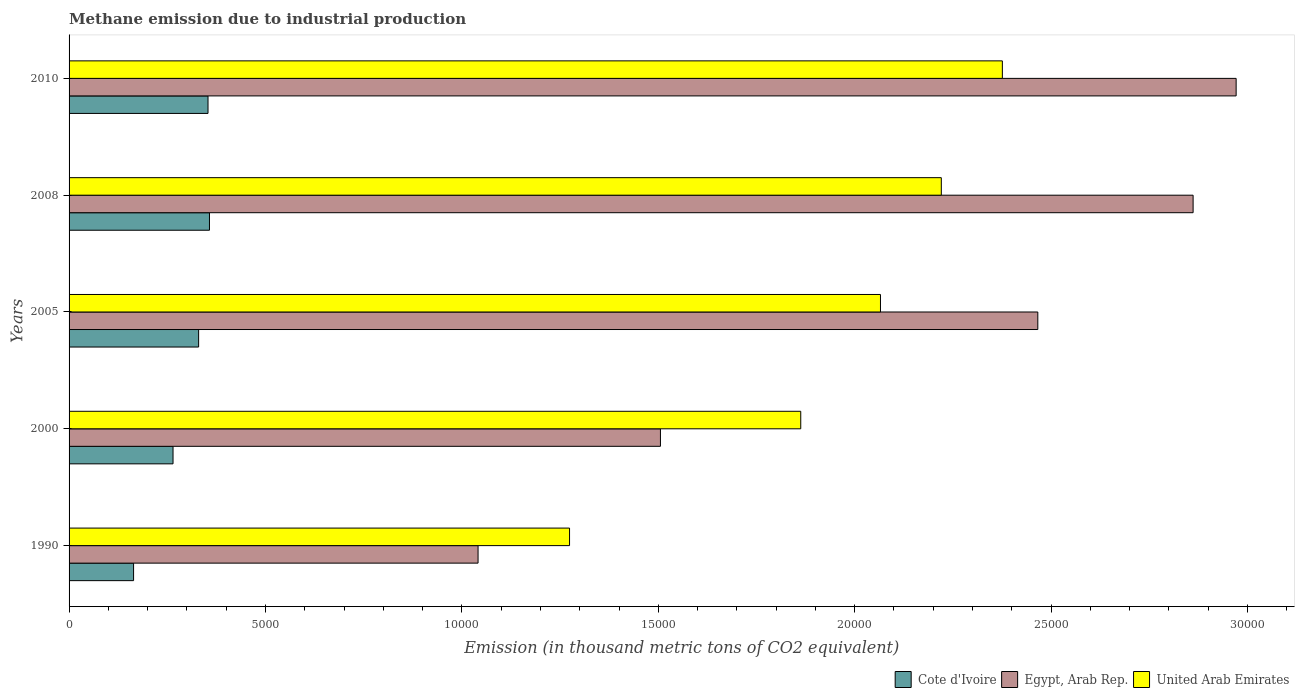How many different coloured bars are there?
Offer a terse response. 3. Are the number of bars per tick equal to the number of legend labels?
Make the answer very short. Yes. What is the label of the 3rd group of bars from the top?
Offer a terse response. 2005. What is the amount of methane emitted in United Arab Emirates in 2008?
Provide a short and direct response. 2.22e+04. Across all years, what is the maximum amount of methane emitted in United Arab Emirates?
Your answer should be very brief. 2.38e+04. Across all years, what is the minimum amount of methane emitted in Cote d'Ivoire?
Offer a very short reply. 1642.3. In which year was the amount of methane emitted in United Arab Emirates maximum?
Ensure brevity in your answer.  2010. What is the total amount of methane emitted in Egypt, Arab Rep. in the graph?
Provide a succinct answer. 1.08e+05. What is the difference between the amount of methane emitted in Egypt, Arab Rep. in 2000 and that in 2008?
Your answer should be very brief. -1.36e+04. What is the difference between the amount of methane emitted in Egypt, Arab Rep. in 1990 and the amount of methane emitted in United Arab Emirates in 2008?
Make the answer very short. -1.18e+04. What is the average amount of methane emitted in Egypt, Arab Rep. per year?
Give a very brief answer. 2.17e+04. In the year 2010, what is the difference between the amount of methane emitted in United Arab Emirates and amount of methane emitted in Cote d'Ivoire?
Provide a short and direct response. 2.02e+04. In how many years, is the amount of methane emitted in Cote d'Ivoire greater than 7000 thousand metric tons?
Give a very brief answer. 0. What is the ratio of the amount of methane emitted in United Arab Emirates in 2005 to that in 2010?
Provide a short and direct response. 0.87. Is the amount of methane emitted in Cote d'Ivoire in 2005 less than that in 2010?
Your answer should be compact. Yes. Is the difference between the amount of methane emitted in United Arab Emirates in 2000 and 2010 greater than the difference between the amount of methane emitted in Cote d'Ivoire in 2000 and 2010?
Your answer should be compact. No. What is the difference between the highest and the second highest amount of methane emitted in Egypt, Arab Rep.?
Your answer should be compact. 1095.6. What is the difference between the highest and the lowest amount of methane emitted in Cote d'Ivoire?
Keep it short and to the point. 1932.1. Is the sum of the amount of methane emitted in United Arab Emirates in 2000 and 2010 greater than the maximum amount of methane emitted in Cote d'Ivoire across all years?
Keep it short and to the point. Yes. What does the 1st bar from the top in 2008 represents?
Offer a very short reply. United Arab Emirates. What does the 3rd bar from the bottom in 2010 represents?
Your answer should be compact. United Arab Emirates. Is it the case that in every year, the sum of the amount of methane emitted in Egypt, Arab Rep. and amount of methane emitted in Cote d'Ivoire is greater than the amount of methane emitted in United Arab Emirates?
Provide a short and direct response. No. Are all the bars in the graph horizontal?
Offer a terse response. Yes. What is the difference between two consecutive major ticks on the X-axis?
Give a very brief answer. 5000. Does the graph contain any zero values?
Offer a terse response. No. Does the graph contain grids?
Keep it short and to the point. No. How many legend labels are there?
Your response must be concise. 3. What is the title of the graph?
Make the answer very short. Methane emission due to industrial production. What is the label or title of the X-axis?
Your answer should be very brief. Emission (in thousand metric tons of CO2 equivalent). What is the Emission (in thousand metric tons of CO2 equivalent) in Cote d'Ivoire in 1990?
Ensure brevity in your answer.  1642.3. What is the Emission (in thousand metric tons of CO2 equivalent) of Egypt, Arab Rep. in 1990?
Keep it short and to the point. 1.04e+04. What is the Emission (in thousand metric tons of CO2 equivalent) of United Arab Emirates in 1990?
Provide a short and direct response. 1.27e+04. What is the Emission (in thousand metric tons of CO2 equivalent) in Cote d'Ivoire in 2000?
Give a very brief answer. 2646.7. What is the Emission (in thousand metric tons of CO2 equivalent) of Egypt, Arab Rep. in 2000?
Make the answer very short. 1.51e+04. What is the Emission (in thousand metric tons of CO2 equivalent) in United Arab Emirates in 2000?
Your answer should be compact. 1.86e+04. What is the Emission (in thousand metric tons of CO2 equivalent) of Cote d'Ivoire in 2005?
Your answer should be very brief. 3298.2. What is the Emission (in thousand metric tons of CO2 equivalent) in Egypt, Arab Rep. in 2005?
Give a very brief answer. 2.47e+04. What is the Emission (in thousand metric tons of CO2 equivalent) of United Arab Emirates in 2005?
Your answer should be compact. 2.07e+04. What is the Emission (in thousand metric tons of CO2 equivalent) of Cote d'Ivoire in 2008?
Provide a succinct answer. 3574.4. What is the Emission (in thousand metric tons of CO2 equivalent) in Egypt, Arab Rep. in 2008?
Ensure brevity in your answer.  2.86e+04. What is the Emission (in thousand metric tons of CO2 equivalent) in United Arab Emirates in 2008?
Offer a very short reply. 2.22e+04. What is the Emission (in thousand metric tons of CO2 equivalent) in Cote d'Ivoire in 2010?
Your answer should be very brief. 3537.3. What is the Emission (in thousand metric tons of CO2 equivalent) of Egypt, Arab Rep. in 2010?
Your answer should be very brief. 2.97e+04. What is the Emission (in thousand metric tons of CO2 equivalent) of United Arab Emirates in 2010?
Provide a short and direct response. 2.38e+04. Across all years, what is the maximum Emission (in thousand metric tons of CO2 equivalent) in Cote d'Ivoire?
Ensure brevity in your answer.  3574.4. Across all years, what is the maximum Emission (in thousand metric tons of CO2 equivalent) of Egypt, Arab Rep.?
Provide a short and direct response. 2.97e+04. Across all years, what is the maximum Emission (in thousand metric tons of CO2 equivalent) in United Arab Emirates?
Your response must be concise. 2.38e+04. Across all years, what is the minimum Emission (in thousand metric tons of CO2 equivalent) of Cote d'Ivoire?
Make the answer very short. 1642.3. Across all years, what is the minimum Emission (in thousand metric tons of CO2 equivalent) in Egypt, Arab Rep.?
Provide a short and direct response. 1.04e+04. Across all years, what is the minimum Emission (in thousand metric tons of CO2 equivalent) in United Arab Emirates?
Offer a very short reply. 1.27e+04. What is the total Emission (in thousand metric tons of CO2 equivalent) in Cote d'Ivoire in the graph?
Offer a terse response. 1.47e+04. What is the total Emission (in thousand metric tons of CO2 equivalent) in Egypt, Arab Rep. in the graph?
Keep it short and to the point. 1.08e+05. What is the total Emission (in thousand metric tons of CO2 equivalent) of United Arab Emirates in the graph?
Provide a succinct answer. 9.80e+04. What is the difference between the Emission (in thousand metric tons of CO2 equivalent) of Cote d'Ivoire in 1990 and that in 2000?
Give a very brief answer. -1004.4. What is the difference between the Emission (in thousand metric tons of CO2 equivalent) in Egypt, Arab Rep. in 1990 and that in 2000?
Provide a succinct answer. -4642.9. What is the difference between the Emission (in thousand metric tons of CO2 equivalent) of United Arab Emirates in 1990 and that in 2000?
Ensure brevity in your answer.  -5885.7. What is the difference between the Emission (in thousand metric tons of CO2 equivalent) of Cote d'Ivoire in 1990 and that in 2005?
Ensure brevity in your answer.  -1655.9. What is the difference between the Emission (in thousand metric tons of CO2 equivalent) in Egypt, Arab Rep. in 1990 and that in 2005?
Your answer should be very brief. -1.42e+04. What is the difference between the Emission (in thousand metric tons of CO2 equivalent) of United Arab Emirates in 1990 and that in 2005?
Your answer should be compact. -7915.3. What is the difference between the Emission (in thousand metric tons of CO2 equivalent) of Cote d'Ivoire in 1990 and that in 2008?
Offer a terse response. -1932.1. What is the difference between the Emission (in thousand metric tons of CO2 equivalent) in Egypt, Arab Rep. in 1990 and that in 2008?
Provide a succinct answer. -1.82e+04. What is the difference between the Emission (in thousand metric tons of CO2 equivalent) of United Arab Emirates in 1990 and that in 2008?
Your answer should be compact. -9464.3. What is the difference between the Emission (in thousand metric tons of CO2 equivalent) of Cote d'Ivoire in 1990 and that in 2010?
Give a very brief answer. -1895. What is the difference between the Emission (in thousand metric tons of CO2 equivalent) in Egypt, Arab Rep. in 1990 and that in 2010?
Offer a terse response. -1.93e+04. What is the difference between the Emission (in thousand metric tons of CO2 equivalent) of United Arab Emirates in 1990 and that in 2010?
Offer a terse response. -1.10e+04. What is the difference between the Emission (in thousand metric tons of CO2 equivalent) in Cote d'Ivoire in 2000 and that in 2005?
Give a very brief answer. -651.5. What is the difference between the Emission (in thousand metric tons of CO2 equivalent) of Egypt, Arab Rep. in 2000 and that in 2005?
Keep it short and to the point. -9607. What is the difference between the Emission (in thousand metric tons of CO2 equivalent) of United Arab Emirates in 2000 and that in 2005?
Your answer should be very brief. -2029.6. What is the difference between the Emission (in thousand metric tons of CO2 equivalent) in Cote d'Ivoire in 2000 and that in 2008?
Offer a very short reply. -927.7. What is the difference between the Emission (in thousand metric tons of CO2 equivalent) of Egypt, Arab Rep. in 2000 and that in 2008?
Make the answer very short. -1.36e+04. What is the difference between the Emission (in thousand metric tons of CO2 equivalent) in United Arab Emirates in 2000 and that in 2008?
Offer a terse response. -3578.6. What is the difference between the Emission (in thousand metric tons of CO2 equivalent) in Cote d'Ivoire in 2000 and that in 2010?
Your answer should be very brief. -890.6. What is the difference between the Emission (in thousand metric tons of CO2 equivalent) of Egypt, Arab Rep. in 2000 and that in 2010?
Make the answer very short. -1.47e+04. What is the difference between the Emission (in thousand metric tons of CO2 equivalent) in United Arab Emirates in 2000 and that in 2010?
Offer a terse response. -5132.6. What is the difference between the Emission (in thousand metric tons of CO2 equivalent) in Cote d'Ivoire in 2005 and that in 2008?
Your answer should be very brief. -276.2. What is the difference between the Emission (in thousand metric tons of CO2 equivalent) of Egypt, Arab Rep. in 2005 and that in 2008?
Your answer should be very brief. -3953.4. What is the difference between the Emission (in thousand metric tons of CO2 equivalent) of United Arab Emirates in 2005 and that in 2008?
Offer a terse response. -1549. What is the difference between the Emission (in thousand metric tons of CO2 equivalent) in Cote d'Ivoire in 2005 and that in 2010?
Your answer should be very brief. -239.1. What is the difference between the Emission (in thousand metric tons of CO2 equivalent) in Egypt, Arab Rep. in 2005 and that in 2010?
Ensure brevity in your answer.  -5049. What is the difference between the Emission (in thousand metric tons of CO2 equivalent) of United Arab Emirates in 2005 and that in 2010?
Provide a succinct answer. -3103. What is the difference between the Emission (in thousand metric tons of CO2 equivalent) of Cote d'Ivoire in 2008 and that in 2010?
Make the answer very short. 37.1. What is the difference between the Emission (in thousand metric tons of CO2 equivalent) of Egypt, Arab Rep. in 2008 and that in 2010?
Give a very brief answer. -1095.6. What is the difference between the Emission (in thousand metric tons of CO2 equivalent) of United Arab Emirates in 2008 and that in 2010?
Offer a very short reply. -1554. What is the difference between the Emission (in thousand metric tons of CO2 equivalent) of Cote d'Ivoire in 1990 and the Emission (in thousand metric tons of CO2 equivalent) of Egypt, Arab Rep. in 2000?
Keep it short and to the point. -1.34e+04. What is the difference between the Emission (in thousand metric tons of CO2 equivalent) in Cote d'Ivoire in 1990 and the Emission (in thousand metric tons of CO2 equivalent) in United Arab Emirates in 2000?
Your answer should be compact. -1.70e+04. What is the difference between the Emission (in thousand metric tons of CO2 equivalent) in Egypt, Arab Rep. in 1990 and the Emission (in thousand metric tons of CO2 equivalent) in United Arab Emirates in 2000?
Keep it short and to the point. -8214.7. What is the difference between the Emission (in thousand metric tons of CO2 equivalent) of Cote d'Ivoire in 1990 and the Emission (in thousand metric tons of CO2 equivalent) of Egypt, Arab Rep. in 2005?
Offer a terse response. -2.30e+04. What is the difference between the Emission (in thousand metric tons of CO2 equivalent) in Cote d'Ivoire in 1990 and the Emission (in thousand metric tons of CO2 equivalent) in United Arab Emirates in 2005?
Keep it short and to the point. -1.90e+04. What is the difference between the Emission (in thousand metric tons of CO2 equivalent) of Egypt, Arab Rep. in 1990 and the Emission (in thousand metric tons of CO2 equivalent) of United Arab Emirates in 2005?
Provide a succinct answer. -1.02e+04. What is the difference between the Emission (in thousand metric tons of CO2 equivalent) of Cote d'Ivoire in 1990 and the Emission (in thousand metric tons of CO2 equivalent) of Egypt, Arab Rep. in 2008?
Make the answer very short. -2.70e+04. What is the difference between the Emission (in thousand metric tons of CO2 equivalent) of Cote d'Ivoire in 1990 and the Emission (in thousand metric tons of CO2 equivalent) of United Arab Emirates in 2008?
Make the answer very short. -2.06e+04. What is the difference between the Emission (in thousand metric tons of CO2 equivalent) in Egypt, Arab Rep. in 1990 and the Emission (in thousand metric tons of CO2 equivalent) in United Arab Emirates in 2008?
Provide a short and direct response. -1.18e+04. What is the difference between the Emission (in thousand metric tons of CO2 equivalent) of Cote d'Ivoire in 1990 and the Emission (in thousand metric tons of CO2 equivalent) of Egypt, Arab Rep. in 2010?
Offer a very short reply. -2.81e+04. What is the difference between the Emission (in thousand metric tons of CO2 equivalent) of Cote d'Ivoire in 1990 and the Emission (in thousand metric tons of CO2 equivalent) of United Arab Emirates in 2010?
Offer a very short reply. -2.21e+04. What is the difference between the Emission (in thousand metric tons of CO2 equivalent) of Egypt, Arab Rep. in 1990 and the Emission (in thousand metric tons of CO2 equivalent) of United Arab Emirates in 2010?
Your answer should be compact. -1.33e+04. What is the difference between the Emission (in thousand metric tons of CO2 equivalent) in Cote d'Ivoire in 2000 and the Emission (in thousand metric tons of CO2 equivalent) in Egypt, Arab Rep. in 2005?
Offer a terse response. -2.20e+04. What is the difference between the Emission (in thousand metric tons of CO2 equivalent) of Cote d'Ivoire in 2000 and the Emission (in thousand metric tons of CO2 equivalent) of United Arab Emirates in 2005?
Provide a short and direct response. -1.80e+04. What is the difference between the Emission (in thousand metric tons of CO2 equivalent) of Egypt, Arab Rep. in 2000 and the Emission (in thousand metric tons of CO2 equivalent) of United Arab Emirates in 2005?
Keep it short and to the point. -5601.4. What is the difference between the Emission (in thousand metric tons of CO2 equivalent) in Cote d'Ivoire in 2000 and the Emission (in thousand metric tons of CO2 equivalent) in Egypt, Arab Rep. in 2008?
Offer a very short reply. -2.60e+04. What is the difference between the Emission (in thousand metric tons of CO2 equivalent) in Cote d'Ivoire in 2000 and the Emission (in thousand metric tons of CO2 equivalent) in United Arab Emirates in 2008?
Offer a terse response. -1.96e+04. What is the difference between the Emission (in thousand metric tons of CO2 equivalent) in Egypt, Arab Rep. in 2000 and the Emission (in thousand metric tons of CO2 equivalent) in United Arab Emirates in 2008?
Give a very brief answer. -7150.4. What is the difference between the Emission (in thousand metric tons of CO2 equivalent) in Cote d'Ivoire in 2000 and the Emission (in thousand metric tons of CO2 equivalent) in Egypt, Arab Rep. in 2010?
Offer a very short reply. -2.71e+04. What is the difference between the Emission (in thousand metric tons of CO2 equivalent) in Cote d'Ivoire in 2000 and the Emission (in thousand metric tons of CO2 equivalent) in United Arab Emirates in 2010?
Make the answer very short. -2.11e+04. What is the difference between the Emission (in thousand metric tons of CO2 equivalent) of Egypt, Arab Rep. in 2000 and the Emission (in thousand metric tons of CO2 equivalent) of United Arab Emirates in 2010?
Your response must be concise. -8704.4. What is the difference between the Emission (in thousand metric tons of CO2 equivalent) in Cote d'Ivoire in 2005 and the Emission (in thousand metric tons of CO2 equivalent) in Egypt, Arab Rep. in 2008?
Offer a terse response. -2.53e+04. What is the difference between the Emission (in thousand metric tons of CO2 equivalent) in Cote d'Ivoire in 2005 and the Emission (in thousand metric tons of CO2 equivalent) in United Arab Emirates in 2008?
Offer a terse response. -1.89e+04. What is the difference between the Emission (in thousand metric tons of CO2 equivalent) in Egypt, Arab Rep. in 2005 and the Emission (in thousand metric tons of CO2 equivalent) in United Arab Emirates in 2008?
Provide a short and direct response. 2456.6. What is the difference between the Emission (in thousand metric tons of CO2 equivalent) in Cote d'Ivoire in 2005 and the Emission (in thousand metric tons of CO2 equivalent) in Egypt, Arab Rep. in 2010?
Offer a very short reply. -2.64e+04. What is the difference between the Emission (in thousand metric tons of CO2 equivalent) in Cote d'Ivoire in 2005 and the Emission (in thousand metric tons of CO2 equivalent) in United Arab Emirates in 2010?
Your answer should be very brief. -2.05e+04. What is the difference between the Emission (in thousand metric tons of CO2 equivalent) of Egypt, Arab Rep. in 2005 and the Emission (in thousand metric tons of CO2 equivalent) of United Arab Emirates in 2010?
Provide a succinct answer. 902.6. What is the difference between the Emission (in thousand metric tons of CO2 equivalent) in Cote d'Ivoire in 2008 and the Emission (in thousand metric tons of CO2 equivalent) in Egypt, Arab Rep. in 2010?
Offer a terse response. -2.61e+04. What is the difference between the Emission (in thousand metric tons of CO2 equivalent) in Cote d'Ivoire in 2008 and the Emission (in thousand metric tons of CO2 equivalent) in United Arab Emirates in 2010?
Your answer should be compact. -2.02e+04. What is the difference between the Emission (in thousand metric tons of CO2 equivalent) of Egypt, Arab Rep. in 2008 and the Emission (in thousand metric tons of CO2 equivalent) of United Arab Emirates in 2010?
Ensure brevity in your answer.  4856. What is the average Emission (in thousand metric tons of CO2 equivalent) of Cote d'Ivoire per year?
Provide a succinct answer. 2939.78. What is the average Emission (in thousand metric tons of CO2 equivalent) of Egypt, Arab Rep. per year?
Keep it short and to the point. 2.17e+04. What is the average Emission (in thousand metric tons of CO2 equivalent) of United Arab Emirates per year?
Keep it short and to the point. 1.96e+04. In the year 1990, what is the difference between the Emission (in thousand metric tons of CO2 equivalent) in Cote d'Ivoire and Emission (in thousand metric tons of CO2 equivalent) in Egypt, Arab Rep.?
Your response must be concise. -8769.7. In the year 1990, what is the difference between the Emission (in thousand metric tons of CO2 equivalent) in Cote d'Ivoire and Emission (in thousand metric tons of CO2 equivalent) in United Arab Emirates?
Your answer should be compact. -1.11e+04. In the year 1990, what is the difference between the Emission (in thousand metric tons of CO2 equivalent) in Egypt, Arab Rep. and Emission (in thousand metric tons of CO2 equivalent) in United Arab Emirates?
Provide a short and direct response. -2329. In the year 2000, what is the difference between the Emission (in thousand metric tons of CO2 equivalent) in Cote d'Ivoire and Emission (in thousand metric tons of CO2 equivalent) in Egypt, Arab Rep.?
Provide a short and direct response. -1.24e+04. In the year 2000, what is the difference between the Emission (in thousand metric tons of CO2 equivalent) of Cote d'Ivoire and Emission (in thousand metric tons of CO2 equivalent) of United Arab Emirates?
Your answer should be compact. -1.60e+04. In the year 2000, what is the difference between the Emission (in thousand metric tons of CO2 equivalent) in Egypt, Arab Rep. and Emission (in thousand metric tons of CO2 equivalent) in United Arab Emirates?
Provide a succinct answer. -3571.8. In the year 2005, what is the difference between the Emission (in thousand metric tons of CO2 equivalent) of Cote d'Ivoire and Emission (in thousand metric tons of CO2 equivalent) of Egypt, Arab Rep.?
Offer a very short reply. -2.14e+04. In the year 2005, what is the difference between the Emission (in thousand metric tons of CO2 equivalent) in Cote d'Ivoire and Emission (in thousand metric tons of CO2 equivalent) in United Arab Emirates?
Offer a terse response. -1.74e+04. In the year 2005, what is the difference between the Emission (in thousand metric tons of CO2 equivalent) in Egypt, Arab Rep. and Emission (in thousand metric tons of CO2 equivalent) in United Arab Emirates?
Make the answer very short. 4005.6. In the year 2008, what is the difference between the Emission (in thousand metric tons of CO2 equivalent) in Cote d'Ivoire and Emission (in thousand metric tons of CO2 equivalent) in Egypt, Arab Rep.?
Provide a short and direct response. -2.50e+04. In the year 2008, what is the difference between the Emission (in thousand metric tons of CO2 equivalent) of Cote d'Ivoire and Emission (in thousand metric tons of CO2 equivalent) of United Arab Emirates?
Your answer should be compact. -1.86e+04. In the year 2008, what is the difference between the Emission (in thousand metric tons of CO2 equivalent) of Egypt, Arab Rep. and Emission (in thousand metric tons of CO2 equivalent) of United Arab Emirates?
Provide a succinct answer. 6410. In the year 2010, what is the difference between the Emission (in thousand metric tons of CO2 equivalent) of Cote d'Ivoire and Emission (in thousand metric tons of CO2 equivalent) of Egypt, Arab Rep.?
Make the answer very short. -2.62e+04. In the year 2010, what is the difference between the Emission (in thousand metric tons of CO2 equivalent) of Cote d'Ivoire and Emission (in thousand metric tons of CO2 equivalent) of United Arab Emirates?
Offer a very short reply. -2.02e+04. In the year 2010, what is the difference between the Emission (in thousand metric tons of CO2 equivalent) in Egypt, Arab Rep. and Emission (in thousand metric tons of CO2 equivalent) in United Arab Emirates?
Offer a very short reply. 5951.6. What is the ratio of the Emission (in thousand metric tons of CO2 equivalent) of Cote d'Ivoire in 1990 to that in 2000?
Provide a short and direct response. 0.62. What is the ratio of the Emission (in thousand metric tons of CO2 equivalent) of Egypt, Arab Rep. in 1990 to that in 2000?
Offer a very short reply. 0.69. What is the ratio of the Emission (in thousand metric tons of CO2 equivalent) of United Arab Emirates in 1990 to that in 2000?
Ensure brevity in your answer.  0.68. What is the ratio of the Emission (in thousand metric tons of CO2 equivalent) in Cote d'Ivoire in 1990 to that in 2005?
Your response must be concise. 0.5. What is the ratio of the Emission (in thousand metric tons of CO2 equivalent) of Egypt, Arab Rep. in 1990 to that in 2005?
Your answer should be compact. 0.42. What is the ratio of the Emission (in thousand metric tons of CO2 equivalent) in United Arab Emirates in 1990 to that in 2005?
Your answer should be compact. 0.62. What is the ratio of the Emission (in thousand metric tons of CO2 equivalent) of Cote d'Ivoire in 1990 to that in 2008?
Provide a succinct answer. 0.46. What is the ratio of the Emission (in thousand metric tons of CO2 equivalent) of Egypt, Arab Rep. in 1990 to that in 2008?
Your answer should be very brief. 0.36. What is the ratio of the Emission (in thousand metric tons of CO2 equivalent) in United Arab Emirates in 1990 to that in 2008?
Offer a terse response. 0.57. What is the ratio of the Emission (in thousand metric tons of CO2 equivalent) of Cote d'Ivoire in 1990 to that in 2010?
Your response must be concise. 0.46. What is the ratio of the Emission (in thousand metric tons of CO2 equivalent) of Egypt, Arab Rep. in 1990 to that in 2010?
Offer a very short reply. 0.35. What is the ratio of the Emission (in thousand metric tons of CO2 equivalent) of United Arab Emirates in 1990 to that in 2010?
Make the answer very short. 0.54. What is the ratio of the Emission (in thousand metric tons of CO2 equivalent) in Cote d'Ivoire in 2000 to that in 2005?
Your answer should be compact. 0.8. What is the ratio of the Emission (in thousand metric tons of CO2 equivalent) in Egypt, Arab Rep. in 2000 to that in 2005?
Give a very brief answer. 0.61. What is the ratio of the Emission (in thousand metric tons of CO2 equivalent) of United Arab Emirates in 2000 to that in 2005?
Offer a very short reply. 0.9. What is the ratio of the Emission (in thousand metric tons of CO2 equivalent) in Cote d'Ivoire in 2000 to that in 2008?
Provide a short and direct response. 0.74. What is the ratio of the Emission (in thousand metric tons of CO2 equivalent) of Egypt, Arab Rep. in 2000 to that in 2008?
Offer a terse response. 0.53. What is the ratio of the Emission (in thousand metric tons of CO2 equivalent) of United Arab Emirates in 2000 to that in 2008?
Ensure brevity in your answer.  0.84. What is the ratio of the Emission (in thousand metric tons of CO2 equivalent) in Cote d'Ivoire in 2000 to that in 2010?
Ensure brevity in your answer.  0.75. What is the ratio of the Emission (in thousand metric tons of CO2 equivalent) of Egypt, Arab Rep. in 2000 to that in 2010?
Your answer should be very brief. 0.51. What is the ratio of the Emission (in thousand metric tons of CO2 equivalent) in United Arab Emirates in 2000 to that in 2010?
Keep it short and to the point. 0.78. What is the ratio of the Emission (in thousand metric tons of CO2 equivalent) of Cote d'Ivoire in 2005 to that in 2008?
Provide a short and direct response. 0.92. What is the ratio of the Emission (in thousand metric tons of CO2 equivalent) of Egypt, Arab Rep. in 2005 to that in 2008?
Your response must be concise. 0.86. What is the ratio of the Emission (in thousand metric tons of CO2 equivalent) of United Arab Emirates in 2005 to that in 2008?
Your answer should be compact. 0.93. What is the ratio of the Emission (in thousand metric tons of CO2 equivalent) in Cote d'Ivoire in 2005 to that in 2010?
Ensure brevity in your answer.  0.93. What is the ratio of the Emission (in thousand metric tons of CO2 equivalent) in Egypt, Arab Rep. in 2005 to that in 2010?
Ensure brevity in your answer.  0.83. What is the ratio of the Emission (in thousand metric tons of CO2 equivalent) of United Arab Emirates in 2005 to that in 2010?
Provide a succinct answer. 0.87. What is the ratio of the Emission (in thousand metric tons of CO2 equivalent) of Cote d'Ivoire in 2008 to that in 2010?
Your answer should be compact. 1.01. What is the ratio of the Emission (in thousand metric tons of CO2 equivalent) of Egypt, Arab Rep. in 2008 to that in 2010?
Offer a terse response. 0.96. What is the ratio of the Emission (in thousand metric tons of CO2 equivalent) of United Arab Emirates in 2008 to that in 2010?
Provide a short and direct response. 0.93. What is the difference between the highest and the second highest Emission (in thousand metric tons of CO2 equivalent) of Cote d'Ivoire?
Provide a succinct answer. 37.1. What is the difference between the highest and the second highest Emission (in thousand metric tons of CO2 equivalent) in Egypt, Arab Rep.?
Give a very brief answer. 1095.6. What is the difference between the highest and the second highest Emission (in thousand metric tons of CO2 equivalent) in United Arab Emirates?
Offer a terse response. 1554. What is the difference between the highest and the lowest Emission (in thousand metric tons of CO2 equivalent) in Cote d'Ivoire?
Your response must be concise. 1932.1. What is the difference between the highest and the lowest Emission (in thousand metric tons of CO2 equivalent) of Egypt, Arab Rep.?
Your answer should be compact. 1.93e+04. What is the difference between the highest and the lowest Emission (in thousand metric tons of CO2 equivalent) in United Arab Emirates?
Your answer should be compact. 1.10e+04. 